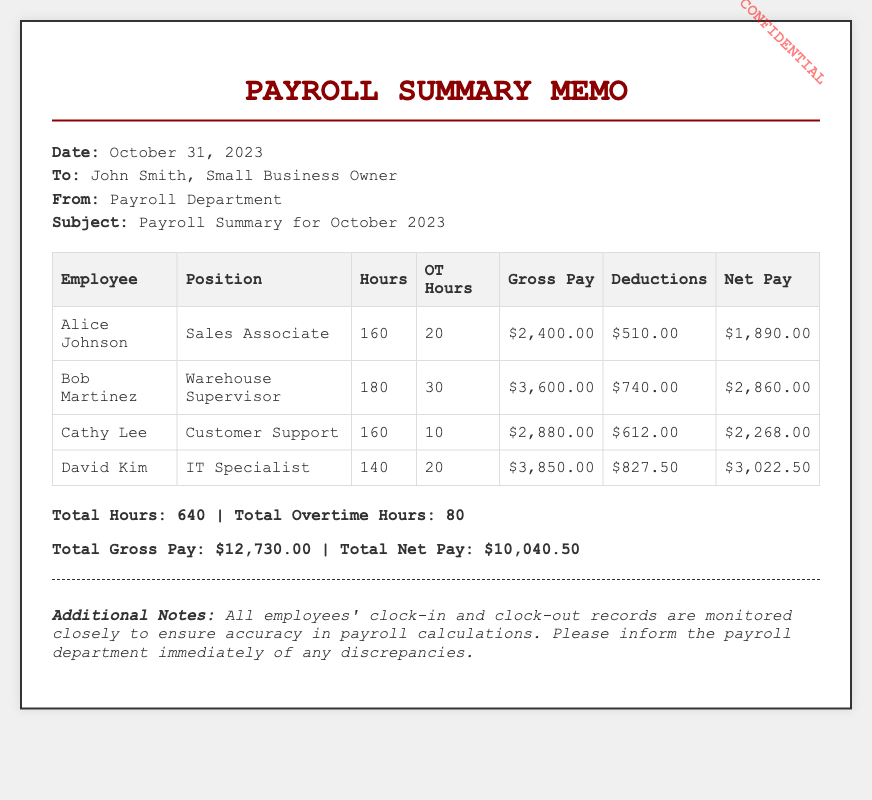What is the date of the memo? The date of the memo is mentioned in the header section of the document.
Answer: October 31, 2023 Who is the recipient of the memo? The recipient of the memo is specified in the header section.
Answer: John Smith How many total employees are listed in the payroll summary? The number of employees is determined by counting the rows in the employee data table.
Answer: 4 What is Alice Johnson's position? Alice Johnson's position is listed in the table under the "Position" column.
Answer: Sales Associate What are the total overtime hours recorded? The total overtime hours are provided in the summary section at the end of the document.
Answer: 80 What is the gross pay for Bob Martinez? Bob Martinez's gross pay is found in the corresponding row in the table.
Answer: $3,600.00 What is the net pay for Cathy Lee? Cathy Lee's net pay is mentioned in the table.
Answer: $2,268.00 What does the memo state about monitoring employees' records? The additional notes section describes the monitoring process for accuracy.
Answer: Monitored closely What is the total gross pay mentioned in the summary? The total gross pay is included in the summary section of the document.
Answer: $12,730.00 